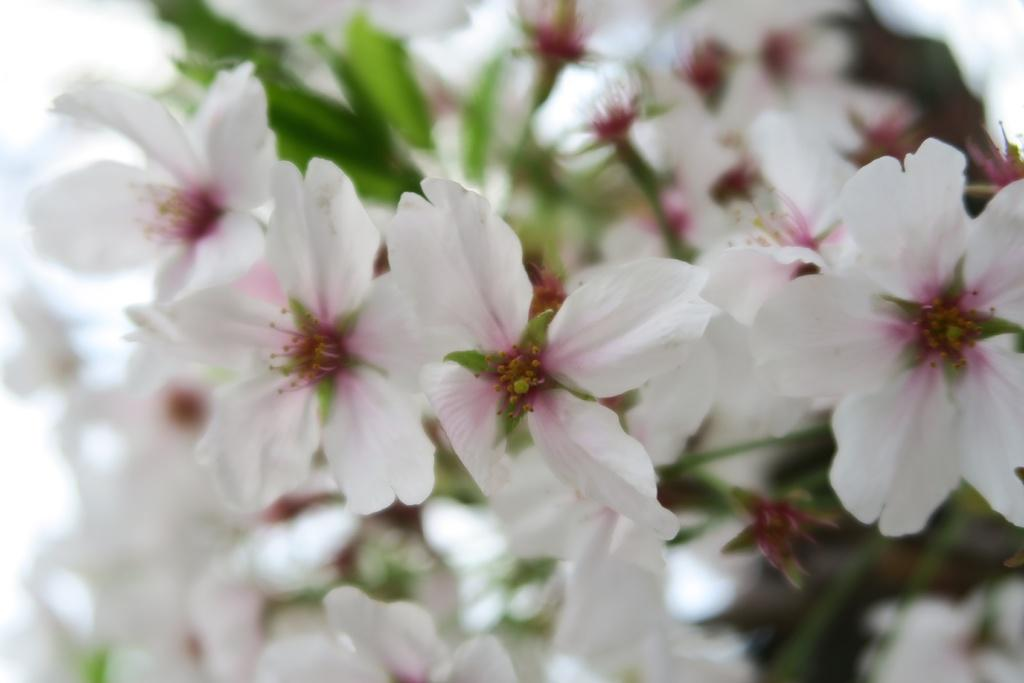What type of flowers are in the image? There are beautiful white flowers in the image. Where are the flowers located? The flowers are on a plant. Can you describe the background of the image? The background of the image is blurry. What rule is being enforced by the flowers in the image? There is no rule being enforced by the flowers in the image; they are simply beautiful white flowers on a plant. How many seeds can be seen in the image? There is no mention of seeds in the image; it features beautiful white flowers on a plant. 